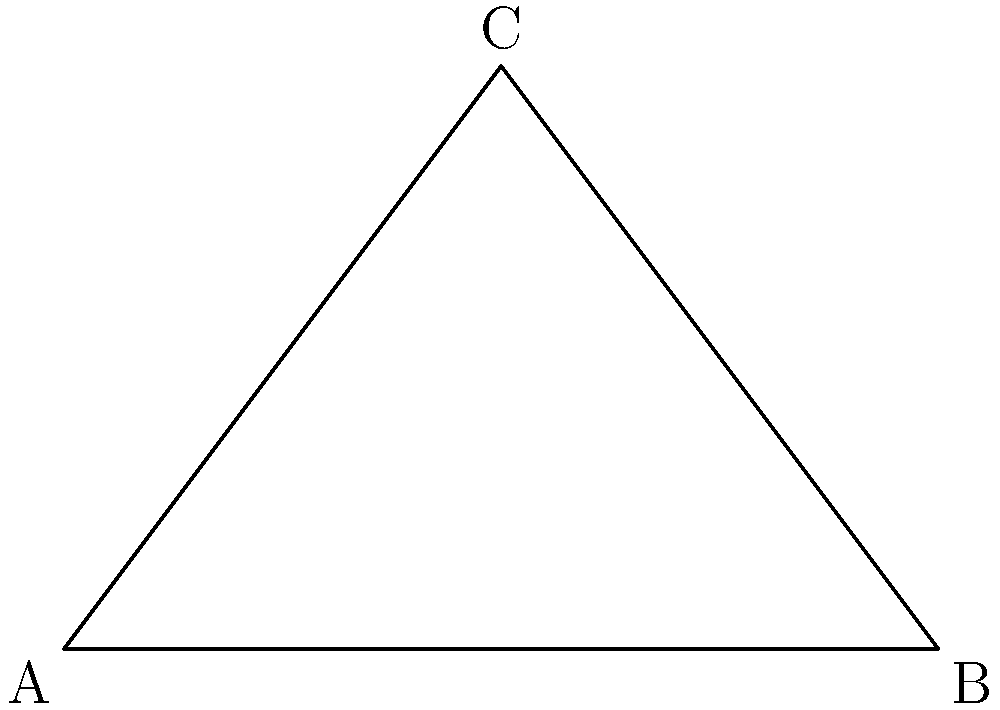In designing a new dress, you need to calculate the optimal angle of fabric drape for the best fit. The dress pattern forms a right-angled triangle ABC, where AB is 6 cm long and represents the waistline. The angle at A is 30°. What is the measure of angle x at B, which represents the fabric drape angle? To solve this problem, let's follow these steps:

1) In a right-angled triangle, the sum of all angles is 180°.

2) We know that:
   - Angle C is 90° (right angle)
   - Angle A is 30°

3) Let's call the angle we're looking for (angle B) x°.

4) We can set up an equation:
   
   $90° + 30° + x° = 180°$

5) Simplify:
   
   $120° + x° = 180°$

6) Subtract 120° from both sides:
   
   $x° = 180° - 120° = 60°$

Therefore, the fabric drape angle (angle B) is 60°.
Answer: 60° 